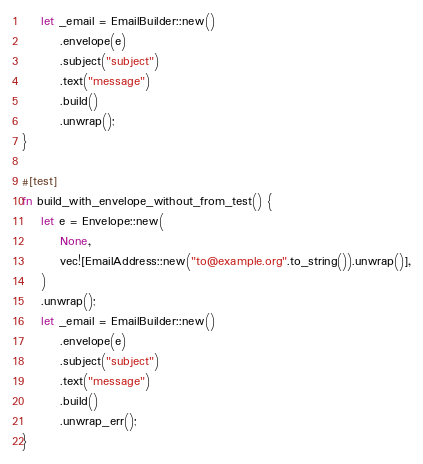Convert code to text. <code><loc_0><loc_0><loc_500><loc_500><_Rust_>    let _email = EmailBuilder::new()
        .envelope(e)
        .subject("subject")
        .text("message")
        .build()
        .unwrap();
}

#[test]
fn build_with_envelope_without_from_test() {
    let e = Envelope::new(
        None,
        vec![EmailAddress::new("to@example.org".to_string()).unwrap()],
    )
    .unwrap();
    let _email = EmailBuilder::new()
        .envelope(e)
        .subject("subject")
        .text("message")
        .build()
        .unwrap_err();
}
</code> 